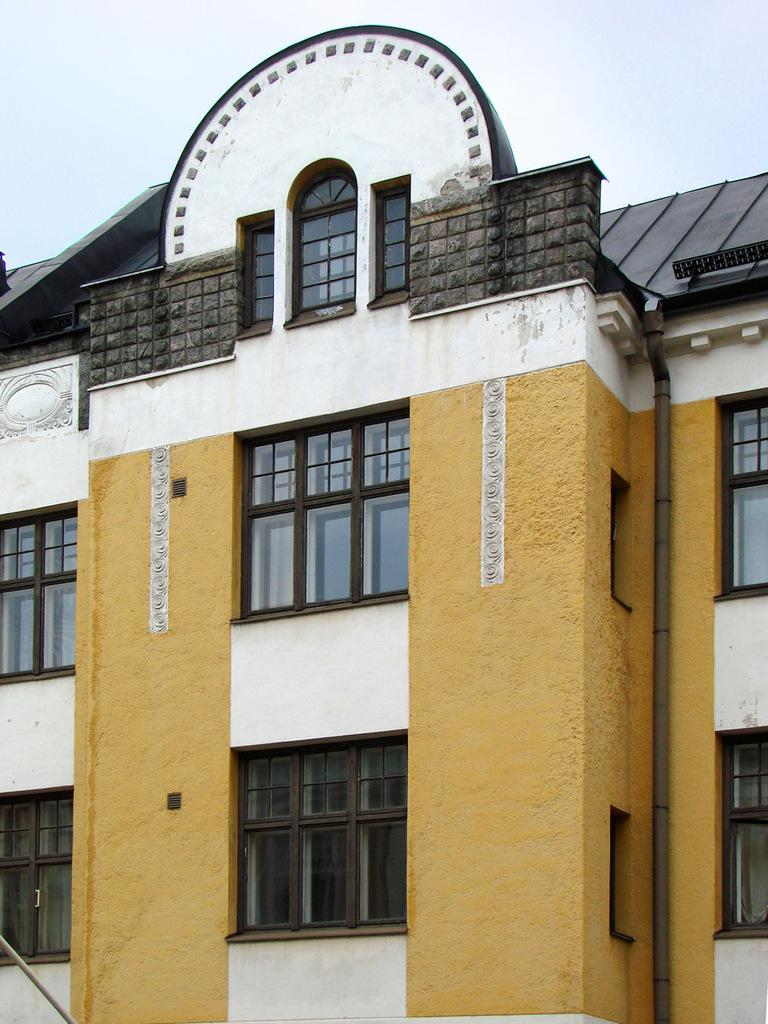What type of structure is in the image? There is a building in the image. Where is the building located in relation to the image? The building is at the front of the image. What can be seen in the background of the image? There is sky visible in the background of the image. How many cables are hanging from the building in the image? There are no cables visible in the image; only the building and sky are present. What historical event is depicted in the image? There is no historical event depicted in the image; it simply shows a building and the sky. 